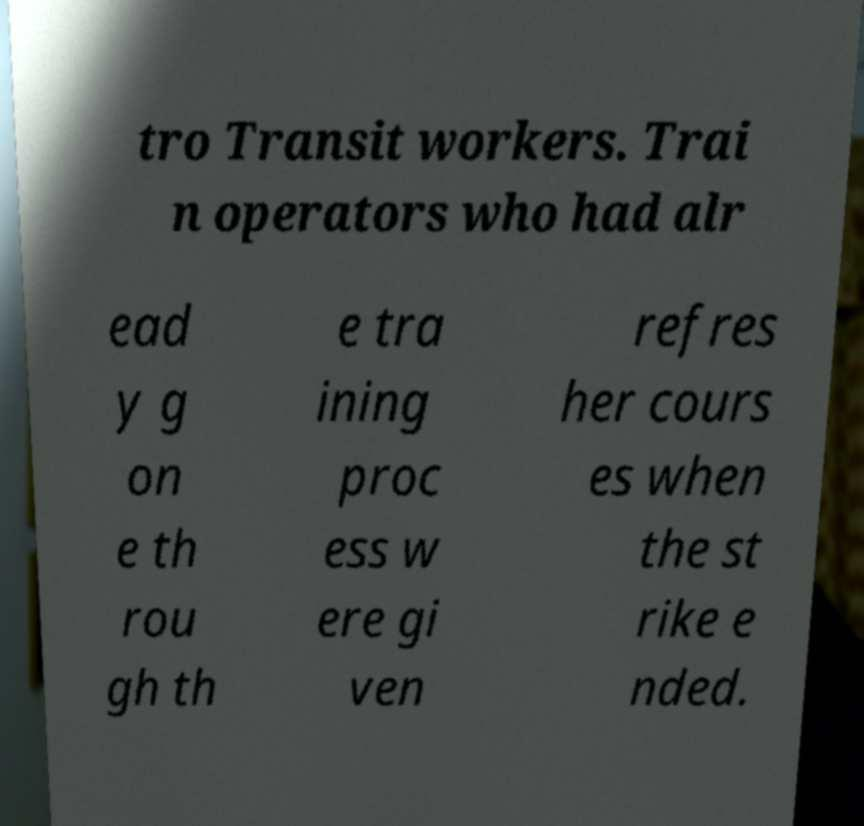There's text embedded in this image that I need extracted. Can you transcribe it verbatim? tro Transit workers. Trai n operators who had alr ead y g on e th rou gh th e tra ining proc ess w ere gi ven refres her cours es when the st rike e nded. 